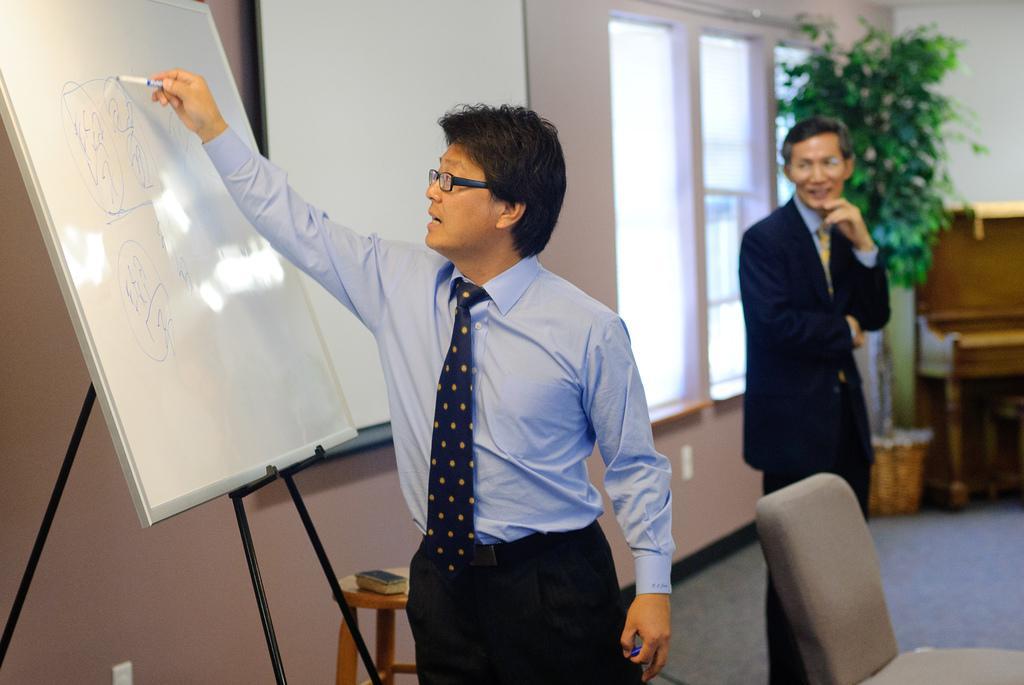Please provide a concise description of this image. In the center of the image there is a person writing on a board. In the background of the image there is another person. There is a window. There is a plant. 